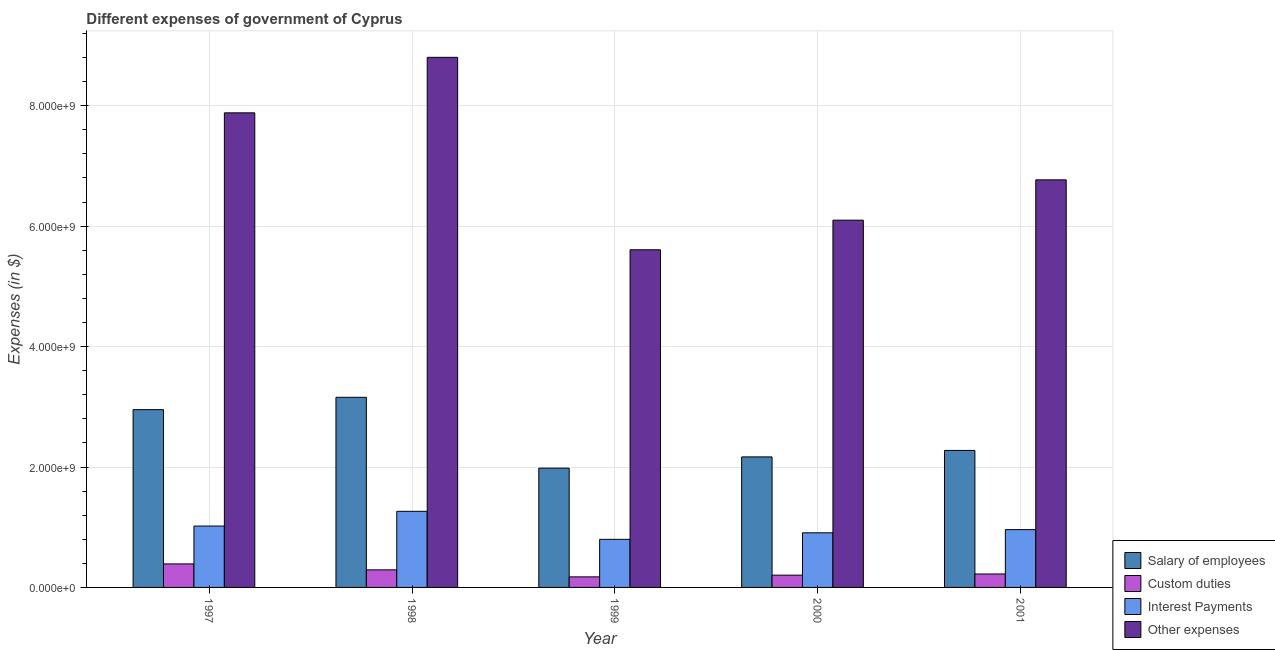Are the number of bars per tick equal to the number of legend labels?
Make the answer very short. Yes. How many bars are there on the 2nd tick from the right?
Give a very brief answer. 4. What is the label of the 2nd group of bars from the left?
Provide a short and direct response. 1998. What is the amount spent on salary of employees in 2000?
Keep it short and to the point. 2.17e+09. Across all years, what is the maximum amount spent on interest payments?
Your answer should be very brief. 1.26e+09. Across all years, what is the minimum amount spent on custom duties?
Give a very brief answer. 1.75e+08. In which year was the amount spent on salary of employees maximum?
Your answer should be very brief. 1998. What is the total amount spent on interest payments in the graph?
Ensure brevity in your answer.  4.95e+09. What is the difference between the amount spent on salary of employees in 1998 and that in 1999?
Your answer should be compact. 1.18e+09. What is the difference between the amount spent on other expenses in 1997 and the amount spent on salary of employees in 2000?
Provide a short and direct response. 1.78e+09. What is the average amount spent on other expenses per year?
Provide a succinct answer. 7.03e+09. What is the ratio of the amount spent on custom duties in 1998 to that in 2000?
Keep it short and to the point. 1.43. What is the difference between the highest and the second highest amount spent on interest payments?
Your answer should be compact. 2.45e+08. What is the difference between the highest and the lowest amount spent on custom duties?
Your answer should be very brief. 2.15e+08. Is the sum of the amount spent on interest payments in 1997 and 2000 greater than the maximum amount spent on custom duties across all years?
Offer a terse response. Yes. What does the 2nd bar from the left in 2001 represents?
Offer a very short reply. Custom duties. What does the 2nd bar from the right in 2000 represents?
Offer a very short reply. Interest Payments. Is it the case that in every year, the sum of the amount spent on salary of employees and amount spent on custom duties is greater than the amount spent on interest payments?
Provide a short and direct response. Yes. How many bars are there?
Give a very brief answer. 20. Are all the bars in the graph horizontal?
Your answer should be compact. No. What is the difference between two consecutive major ticks on the Y-axis?
Provide a short and direct response. 2.00e+09. Are the values on the major ticks of Y-axis written in scientific E-notation?
Offer a terse response. Yes. Does the graph contain grids?
Offer a very short reply. Yes. What is the title of the graph?
Ensure brevity in your answer.  Different expenses of government of Cyprus. Does "Secondary vocational education" appear as one of the legend labels in the graph?
Keep it short and to the point. No. What is the label or title of the X-axis?
Offer a very short reply. Year. What is the label or title of the Y-axis?
Your answer should be very brief. Expenses (in $). What is the Expenses (in $) in Salary of employees in 1997?
Offer a very short reply. 2.95e+09. What is the Expenses (in $) in Custom duties in 1997?
Ensure brevity in your answer.  3.91e+08. What is the Expenses (in $) in Interest Payments in 1997?
Provide a succinct answer. 1.02e+09. What is the Expenses (in $) of Other expenses in 1997?
Offer a very short reply. 7.88e+09. What is the Expenses (in $) of Salary of employees in 1998?
Ensure brevity in your answer.  3.16e+09. What is the Expenses (in $) of Custom duties in 1998?
Your answer should be compact. 2.92e+08. What is the Expenses (in $) in Interest Payments in 1998?
Your answer should be very brief. 1.26e+09. What is the Expenses (in $) of Other expenses in 1998?
Offer a very short reply. 8.80e+09. What is the Expenses (in $) in Salary of employees in 1999?
Make the answer very short. 1.98e+09. What is the Expenses (in $) of Custom duties in 1999?
Offer a terse response. 1.75e+08. What is the Expenses (in $) of Interest Payments in 1999?
Offer a very short reply. 7.99e+08. What is the Expenses (in $) in Other expenses in 1999?
Offer a terse response. 5.61e+09. What is the Expenses (in $) of Salary of employees in 2000?
Offer a terse response. 2.17e+09. What is the Expenses (in $) in Custom duties in 2000?
Keep it short and to the point. 2.04e+08. What is the Expenses (in $) in Interest Payments in 2000?
Offer a very short reply. 9.07e+08. What is the Expenses (in $) of Other expenses in 2000?
Provide a short and direct response. 6.10e+09. What is the Expenses (in $) in Salary of employees in 2001?
Your answer should be compact. 2.28e+09. What is the Expenses (in $) in Custom duties in 2001?
Keep it short and to the point. 2.23e+08. What is the Expenses (in $) of Interest Payments in 2001?
Your answer should be very brief. 9.60e+08. What is the Expenses (in $) in Other expenses in 2001?
Your response must be concise. 6.77e+09. Across all years, what is the maximum Expenses (in $) of Salary of employees?
Provide a short and direct response. 3.16e+09. Across all years, what is the maximum Expenses (in $) in Custom duties?
Your answer should be compact. 3.91e+08. Across all years, what is the maximum Expenses (in $) of Interest Payments?
Your answer should be very brief. 1.26e+09. Across all years, what is the maximum Expenses (in $) in Other expenses?
Offer a terse response. 8.80e+09. Across all years, what is the minimum Expenses (in $) of Salary of employees?
Your answer should be very brief. 1.98e+09. Across all years, what is the minimum Expenses (in $) in Custom duties?
Provide a short and direct response. 1.75e+08. Across all years, what is the minimum Expenses (in $) of Interest Payments?
Offer a terse response. 7.99e+08. Across all years, what is the minimum Expenses (in $) in Other expenses?
Offer a terse response. 5.61e+09. What is the total Expenses (in $) of Salary of employees in the graph?
Give a very brief answer. 1.25e+1. What is the total Expenses (in $) in Custom duties in the graph?
Give a very brief answer. 1.29e+09. What is the total Expenses (in $) of Interest Payments in the graph?
Offer a terse response. 4.95e+09. What is the total Expenses (in $) of Other expenses in the graph?
Your answer should be compact. 3.52e+1. What is the difference between the Expenses (in $) of Salary of employees in 1997 and that in 1998?
Ensure brevity in your answer.  -2.05e+08. What is the difference between the Expenses (in $) in Custom duties in 1997 and that in 1998?
Provide a short and direct response. 9.87e+07. What is the difference between the Expenses (in $) of Interest Payments in 1997 and that in 1998?
Offer a terse response. -2.45e+08. What is the difference between the Expenses (in $) of Other expenses in 1997 and that in 1998?
Give a very brief answer. -9.22e+08. What is the difference between the Expenses (in $) of Salary of employees in 1997 and that in 1999?
Give a very brief answer. 9.71e+08. What is the difference between the Expenses (in $) in Custom duties in 1997 and that in 1999?
Offer a terse response. 2.15e+08. What is the difference between the Expenses (in $) in Interest Payments in 1997 and that in 1999?
Keep it short and to the point. 2.20e+08. What is the difference between the Expenses (in $) of Other expenses in 1997 and that in 1999?
Ensure brevity in your answer.  2.27e+09. What is the difference between the Expenses (in $) of Salary of employees in 1997 and that in 2000?
Give a very brief answer. 7.85e+08. What is the difference between the Expenses (in $) of Custom duties in 1997 and that in 2000?
Ensure brevity in your answer.  1.87e+08. What is the difference between the Expenses (in $) in Interest Payments in 1997 and that in 2000?
Your response must be concise. 1.12e+08. What is the difference between the Expenses (in $) in Other expenses in 1997 and that in 2000?
Your answer should be compact. 1.78e+09. What is the difference between the Expenses (in $) of Salary of employees in 1997 and that in 2001?
Offer a terse response. 6.77e+08. What is the difference between the Expenses (in $) in Custom duties in 1997 and that in 2001?
Your answer should be very brief. 1.67e+08. What is the difference between the Expenses (in $) in Interest Payments in 1997 and that in 2001?
Provide a succinct answer. 5.91e+07. What is the difference between the Expenses (in $) of Other expenses in 1997 and that in 2001?
Offer a very short reply. 1.11e+09. What is the difference between the Expenses (in $) of Salary of employees in 1998 and that in 1999?
Provide a short and direct response. 1.18e+09. What is the difference between the Expenses (in $) of Custom duties in 1998 and that in 1999?
Offer a terse response. 1.16e+08. What is the difference between the Expenses (in $) of Interest Payments in 1998 and that in 1999?
Your answer should be very brief. 4.65e+08. What is the difference between the Expenses (in $) of Other expenses in 1998 and that in 1999?
Provide a short and direct response. 3.20e+09. What is the difference between the Expenses (in $) in Salary of employees in 1998 and that in 2000?
Your response must be concise. 9.90e+08. What is the difference between the Expenses (in $) in Custom duties in 1998 and that in 2000?
Offer a terse response. 8.79e+07. What is the difference between the Expenses (in $) in Interest Payments in 1998 and that in 2000?
Give a very brief answer. 3.57e+08. What is the difference between the Expenses (in $) in Other expenses in 1998 and that in 2000?
Offer a terse response. 2.70e+09. What is the difference between the Expenses (in $) in Salary of employees in 1998 and that in 2001?
Make the answer very short. 8.82e+08. What is the difference between the Expenses (in $) of Custom duties in 1998 and that in 2001?
Your answer should be compact. 6.86e+07. What is the difference between the Expenses (in $) of Interest Payments in 1998 and that in 2001?
Offer a terse response. 3.04e+08. What is the difference between the Expenses (in $) in Other expenses in 1998 and that in 2001?
Provide a succinct answer. 2.03e+09. What is the difference between the Expenses (in $) of Salary of employees in 1999 and that in 2000?
Offer a very short reply. -1.87e+08. What is the difference between the Expenses (in $) in Custom duties in 1999 and that in 2000?
Give a very brief answer. -2.85e+07. What is the difference between the Expenses (in $) of Interest Payments in 1999 and that in 2000?
Your answer should be very brief. -1.08e+08. What is the difference between the Expenses (in $) in Other expenses in 1999 and that in 2000?
Give a very brief answer. -4.92e+08. What is the difference between the Expenses (in $) of Salary of employees in 1999 and that in 2001?
Make the answer very short. -2.94e+08. What is the difference between the Expenses (in $) in Custom duties in 1999 and that in 2001?
Offer a terse response. -4.78e+07. What is the difference between the Expenses (in $) in Interest Payments in 1999 and that in 2001?
Make the answer very short. -1.61e+08. What is the difference between the Expenses (in $) of Other expenses in 1999 and that in 2001?
Offer a terse response. -1.16e+09. What is the difference between the Expenses (in $) of Salary of employees in 2000 and that in 2001?
Provide a succinct answer. -1.07e+08. What is the difference between the Expenses (in $) in Custom duties in 2000 and that in 2001?
Provide a succinct answer. -1.93e+07. What is the difference between the Expenses (in $) in Interest Payments in 2000 and that in 2001?
Make the answer very short. -5.28e+07. What is the difference between the Expenses (in $) of Other expenses in 2000 and that in 2001?
Provide a succinct answer. -6.70e+08. What is the difference between the Expenses (in $) in Salary of employees in 1997 and the Expenses (in $) in Custom duties in 1998?
Offer a very short reply. 2.66e+09. What is the difference between the Expenses (in $) of Salary of employees in 1997 and the Expenses (in $) of Interest Payments in 1998?
Offer a very short reply. 1.69e+09. What is the difference between the Expenses (in $) in Salary of employees in 1997 and the Expenses (in $) in Other expenses in 1998?
Make the answer very short. -5.85e+09. What is the difference between the Expenses (in $) of Custom duties in 1997 and the Expenses (in $) of Interest Payments in 1998?
Ensure brevity in your answer.  -8.73e+08. What is the difference between the Expenses (in $) of Custom duties in 1997 and the Expenses (in $) of Other expenses in 1998?
Offer a terse response. -8.41e+09. What is the difference between the Expenses (in $) in Interest Payments in 1997 and the Expenses (in $) in Other expenses in 1998?
Your answer should be very brief. -7.78e+09. What is the difference between the Expenses (in $) of Salary of employees in 1997 and the Expenses (in $) of Custom duties in 1999?
Give a very brief answer. 2.78e+09. What is the difference between the Expenses (in $) in Salary of employees in 1997 and the Expenses (in $) in Interest Payments in 1999?
Give a very brief answer. 2.15e+09. What is the difference between the Expenses (in $) of Salary of employees in 1997 and the Expenses (in $) of Other expenses in 1999?
Make the answer very short. -2.66e+09. What is the difference between the Expenses (in $) of Custom duties in 1997 and the Expenses (in $) of Interest Payments in 1999?
Provide a short and direct response. -4.08e+08. What is the difference between the Expenses (in $) in Custom duties in 1997 and the Expenses (in $) in Other expenses in 1999?
Your answer should be very brief. -5.22e+09. What is the difference between the Expenses (in $) of Interest Payments in 1997 and the Expenses (in $) of Other expenses in 1999?
Offer a terse response. -4.59e+09. What is the difference between the Expenses (in $) of Salary of employees in 1997 and the Expenses (in $) of Custom duties in 2000?
Offer a very short reply. 2.75e+09. What is the difference between the Expenses (in $) in Salary of employees in 1997 and the Expenses (in $) in Interest Payments in 2000?
Keep it short and to the point. 2.05e+09. What is the difference between the Expenses (in $) of Salary of employees in 1997 and the Expenses (in $) of Other expenses in 2000?
Provide a succinct answer. -3.15e+09. What is the difference between the Expenses (in $) of Custom duties in 1997 and the Expenses (in $) of Interest Payments in 2000?
Provide a short and direct response. -5.17e+08. What is the difference between the Expenses (in $) in Custom duties in 1997 and the Expenses (in $) in Other expenses in 2000?
Give a very brief answer. -5.71e+09. What is the difference between the Expenses (in $) of Interest Payments in 1997 and the Expenses (in $) of Other expenses in 2000?
Give a very brief answer. -5.08e+09. What is the difference between the Expenses (in $) of Salary of employees in 1997 and the Expenses (in $) of Custom duties in 2001?
Offer a very short reply. 2.73e+09. What is the difference between the Expenses (in $) of Salary of employees in 1997 and the Expenses (in $) of Interest Payments in 2001?
Ensure brevity in your answer.  1.99e+09. What is the difference between the Expenses (in $) in Salary of employees in 1997 and the Expenses (in $) in Other expenses in 2001?
Your answer should be very brief. -3.82e+09. What is the difference between the Expenses (in $) in Custom duties in 1997 and the Expenses (in $) in Interest Payments in 2001?
Provide a succinct answer. -5.69e+08. What is the difference between the Expenses (in $) of Custom duties in 1997 and the Expenses (in $) of Other expenses in 2001?
Provide a short and direct response. -6.38e+09. What is the difference between the Expenses (in $) in Interest Payments in 1997 and the Expenses (in $) in Other expenses in 2001?
Your answer should be compact. -5.75e+09. What is the difference between the Expenses (in $) of Salary of employees in 1998 and the Expenses (in $) of Custom duties in 1999?
Keep it short and to the point. 2.98e+09. What is the difference between the Expenses (in $) of Salary of employees in 1998 and the Expenses (in $) of Interest Payments in 1999?
Provide a succinct answer. 2.36e+09. What is the difference between the Expenses (in $) in Salary of employees in 1998 and the Expenses (in $) in Other expenses in 1999?
Offer a terse response. -2.45e+09. What is the difference between the Expenses (in $) of Custom duties in 1998 and the Expenses (in $) of Interest Payments in 1999?
Make the answer very short. -5.07e+08. What is the difference between the Expenses (in $) in Custom duties in 1998 and the Expenses (in $) in Other expenses in 1999?
Ensure brevity in your answer.  -5.32e+09. What is the difference between the Expenses (in $) in Interest Payments in 1998 and the Expenses (in $) in Other expenses in 1999?
Offer a terse response. -4.34e+09. What is the difference between the Expenses (in $) in Salary of employees in 1998 and the Expenses (in $) in Custom duties in 2000?
Offer a very short reply. 2.95e+09. What is the difference between the Expenses (in $) in Salary of employees in 1998 and the Expenses (in $) in Interest Payments in 2000?
Provide a short and direct response. 2.25e+09. What is the difference between the Expenses (in $) in Salary of employees in 1998 and the Expenses (in $) in Other expenses in 2000?
Make the answer very short. -2.94e+09. What is the difference between the Expenses (in $) of Custom duties in 1998 and the Expenses (in $) of Interest Payments in 2000?
Provide a short and direct response. -6.15e+08. What is the difference between the Expenses (in $) of Custom duties in 1998 and the Expenses (in $) of Other expenses in 2000?
Keep it short and to the point. -5.81e+09. What is the difference between the Expenses (in $) of Interest Payments in 1998 and the Expenses (in $) of Other expenses in 2000?
Give a very brief answer. -4.84e+09. What is the difference between the Expenses (in $) in Salary of employees in 1998 and the Expenses (in $) in Custom duties in 2001?
Offer a terse response. 2.93e+09. What is the difference between the Expenses (in $) in Salary of employees in 1998 and the Expenses (in $) in Interest Payments in 2001?
Offer a terse response. 2.20e+09. What is the difference between the Expenses (in $) of Salary of employees in 1998 and the Expenses (in $) of Other expenses in 2001?
Your answer should be very brief. -3.61e+09. What is the difference between the Expenses (in $) of Custom duties in 1998 and the Expenses (in $) of Interest Payments in 2001?
Your answer should be compact. -6.68e+08. What is the difference between the Expenses (in $) of Custom duties in 1998 and the Expenses (in $) of Other expenses in 2001?
Offer a terse response. -6.48e+09. What is the difference between the Expenses (in $) in Interest Payments in 1998 and the Expenses (in $) in Other expenses in 2001?
Ensure brevity in your answer.  -5.51e+09. What is the difference between the Expenses (in $) of Salary of employees in 1999 and the Expenses (in $) of Custom duties in 2000?
Ensure brevity in your answer.  1.78e+09. What is the difference between the Expenses (in $) in Salary of employees in 1999 and the Expenses (in $) in Interest Payments in 2000?
Your answer should be very brief. 1.07e+09. What is the difference between the Expenses (in $) in Salary of employees in 1999 and the Expenses (in $) in Other expenses in 2000?
Ensure brevity in your answer.  -4.12e+09. What is the difference between the Expenses (in $) in Custom duties in 1999 and the Expenses (in $) in Interest Payments in 2000?
Provide a short and direct response. -7.32e+08. What is the difference between the Expenses (in $) in Custom duties in 1999 and the Expenses (in $) in Other expenses in 2000?
Ensure brevity in your answer.  -5.92e+09. What is the difference between the Expenses (in $) of Interest Payments in 1999 and the Expenses (in $) of Other expenses in 2000?
Your answer should be compact. -5.30e+09. What is the difference between the Expenses (in $) in Salary of employees in 1999 and the Expenses (in $) in Custom duties in 2001?
Your answer should be compact. 1.76e+09. What is the difference between the Expenses (in $) in Salary of employees in 1999 and the Expenses (in $) in Interest Payments in 2001?
Your answer should be very brief. 1.02e+09. What is the difference between the Expenses (in $) in Salary of employees in 1999 and the Expenses (in $) in Other expenses in 2001?
Your answer should be very brief. -4.79e+09. What is the difference between the Expenses (in $) of Custom duties in 1999 and the Expenses (in $) of Interest Payments in 2001?
Keep it short and to the point. -7.85e+08. What is the difference between the Expenses (in $) in Custom duties in 1999 and the Expenses (in $) in Other expenses in 2001?
Provide a succinct answer. -6.59e+09. What is the difference between the Expenses (in $) of Interest Payments in 1999 and the Expenses (in $) of Other expenses in 2001?
Provide a short and direct response. -5.97e+09. What is the difference between the Expenses (in $) in Salary of employees in 2000 and the Expenses (in $) in Custom duties in 2001?
Ensure brevity in your answer.  1.94e+09. What is the difference between the Expenses (in $) in Salary of employees in 2000 and the Expenses (in $) in Interest Payments in 2001?
Give a very brief answer. 1.21e+09. What is the difference between the Expenses (in $) of Salary of employees in 2000 and the Expenses (in $) of Other expenses in 2001?
Your answer should be compact. -4.60e+09. What is the difference between the Expenses (in $) in Custom duties in 2000 and the Expenses (in $) in Interest Payments in 2001?
Keep it short and to the point. -7.56e+08. What is the difference between the Expenses (in $) of Custom duties in 2000 and the Expenses (in $) of Other expenses in 2001?
Ensure brevity in your answer.  -6.57e+09. What is the difference between the Expenses (in $) in Interest Payments in 2000 and the Expenses (in $) in Other expenses in 2001?
Your answer should be very brief. -5.86e+09. What is the average Expenses (in $) in Salary of employees per year?
Ensure brevity in your answer.  2.51e+09. What is the average Expenses (in $) of Custom duties per year?
Provide a short and direct response. 2.57e+08. What is the average Expenses (in $) of Interest Payments per year?
Provide a succinct answer. 9.90e+08. What is the average Expenses (in $) in Other expenses per year?
Provide a succinct answer. 7.03e+09. In the year 1997, what is the difference between the Expenses (in $) in Salary of employees and Expenses (in $) in Custom duties?
Your answer should be compact. 2.56e+09. In the year 1997, what is the difference between the Expenses (in $) of Salary of employees and Expenses (in $) of Interest Payments?
Give a very brief answer. 1.93e+09. In the year 1997, what is the difference between the Expenses (in $) of Salary of employees and Expenses (in $) of Other expenses?
Your answer should be very brief. -4.93e+09. In the year 1997, what is the difference between the Expenses (in $) in Custom duties and Expenses (in $) in Interest Payments?
Provide a succinct answer. -6.29e+08. In the year 1997, what is the difference between the Expenses (in $) of Custom duties and Expenses (in $) of Other expenses?
Ensure brevity in your answer.  -7.49e+09. In the year 1997, what is the difference between the Expenses (in $) in Interest Payments and Expenses (in $) in Other expenses?
Make the answer very short. -6.86e+09. In the year 1998, what is the difference between the Expenses (in $) of Salary of employees and Expenses (in $) of Custom duties?
Your answer should be compact. 2.87e+09. In the year 1998, what is the difference between the Expenses (in $) in Salary of employees and Expenses (in $) in Interest Payments?
Give a very brief answer. 1.89e+09. In the year 1998, what is the difference between the Expenses (in $) of Salary of employees and Expenses (in $) of Other expenses?
Your response must be concise. -5.65e+09. In the year 1998, what is the difference between the Expenses (in $) of Custom duties and Expenses (in $) of Interest Payments?
Your answer should be very brief. -9.72e+08. In the year 1998, what is the difference between the Expenses (in $) in Custom duties and Expenses (in $) in Other expenses?
Your answer should be very brief. -8.51e+09. In the year 1998, what is the difference between the Expenses (in $) in Interest Payments and Expenses (in $) in Other expenses?
Ensure brevity in your answer.  -7.54e+09. In the year 1999, what is the difference between the Expenses (in $) in Salary of employees and Expenses (in $) in Custom duties?
Offer a terse response. 1.81e+09. In the year 1999, what is the difference between the Expenses (in $) in Salary of employees and Expenses (in $) in Interest Payments?
Provide a succinct answer. 1.18e+09. In the year 1999, what is the difference between the Expenses (in $) in Salary of employees and Expenses (in $) in Other expenses?
Your answer should be very brief. -3.63e+09. In the year 1999, what is the difference between the Expenses (in $) of Custom duties and Expenses (in $) of Interest Payments?
Provide a short and direct response. -6.23e+08. In the year 1999, what is the difference between the Expenses (in $) of Custom duties and Expenses (in $) of Other expenses?
Offer a very short reply. -5.43e+09. In the year 1999, what is the difference between the Expenses (in $) in Interest Payments and Expenses (in $) in Other expenses?
Offer a very short reply. -4.81e+09. In the year 2000, what is the difference between the Expenses (in $) in Salary of employees and Expenses (in $) in Custom duties?
Give a very brief answer. 1.96e+09. In the year 2000, what is the difference between the Expenses (in $) of Salary of employees and Expenses (in $) of Interest Payments?
Your response must be concise. 1.26e+09. In the year 2000, what is the difference between the Expenses (in $) in Salary of employees and Expenses (in $) in Other expenses?
Keep it short and to the point. -3.93e+09. In the year 2000, what is the difference between the Expenses (in $) in Custom duties and Expenses (in $) in Interest Payments?
Provide a short and direct response. -7.03e+08. In the year 2000, what is the difference between the Expenses (in $) in Custom duties and Expenses (in $) in Other expenses?
Give a very brief answer. -5.90e+09. In the year 2000, what is the difference between the Expenses (in $) in Interest Payments and Expenses (in $) in Other expenses?
Ensure brevity in your answer.  -5.19e+09. In the year 2001, what is the difference between the Expenses (in $) of Salary of employees and Expenses (in $) of Custom duties?
Offer a terse response. 2.05e+09. In the year 2001, what is the difference between the Expenses (in $) in Salary of employees and Expenses (in $) in Interest Payments?
Offer a very short reply. 1.32e+09. In the year 2001, what is the difference between the Expenses (in $) in Salary of employees and Expenses (in $) in Other expenses?
Give a very brief answer. -4.49e+09. In the year 2001, what is the difference between the Expenses (in $) of Custom duties and Expenses (in $) of Interest Payments?
Your response must be concise. -7.37e+08. In the year 2001, what is the difference between the Expenses (in $) of Custom duties and Expenses (in $) of Other expenses?
Keep it short and to the point. -6.55e+09. In the year 2001, what is the difference between the Expenses (in $) in Interest Payments and Expenses (in $) in Other expenses?
Offer a very short reply. -5.81e+09. What is the ratio of the Expenses (in $) of Salary of employees in 1997 to that in 1998?
Your answer should be compact. 0.94. What is the ratio of the Expenses (in $) in Custom duties in 1997 to that in 1998?
Provide a short and direct response. 1.34. What is the ratio of the Expenses (in $) of Interest Payments in 1997 to that in 1998?
Keep it short and to the point. 0.81. What is the ratio of the Expenses (in $) of Other expenses in 1997 to that in 1998?
Your answer should be compact. 0.9. What is the ratio of the Expenses (in $) in Salary of employees in 1997 to that in 1999?
Keep it short and to the point. 1.49. What is the ratio of the Expenses (in $) in Custom duties in 1997 to that in 1999?
Make the answer very short. 2.23. What is the ratio of the Expenses (in $) in Interest Payments in 1997 to that in 1999?
Offer a terse response. 1.28. What is the ratio of the Expenses (in $) in Other expenses in 1997 to that in 1999?
Keep it short and to the point. 1.41. What is the ratio of the Expenses (in $) of Salary of employees in 1997 to that in 2000?
Provide a short and direct response. 1.36. What is the ratio of the Expenses (in $) in Custom duties in 1997 to that in 2000?
Make the answer very short. 1.91. What is the ratio of the Expenses (in $) in Interest Payments in 1997 to that in 2000?
Your response must be concise. 1.12. What is the ratio of the Expenses (in $) in Other expenses in 1997 to that in 2000?
Provide a short and direct response. 1.29. What is the ratio of the Expenses (in $) of Salary of employees in 1997 to that in 2001?
Keep it short and to the point. 1.3. What is the ratio of the Expenses (in $) in Custom duties in 1997 to that in 2001?
Your answer should be compact. 1.75. What is the ratio of the Expenses (in $) in Interest Payments in 1997 to that in 2001?
Offer a terse response. 1.06. What is the ratio of the Expenses (in $) in Other expenses in 1997 to that in 2001?
Give a very brief answer. 1.16. What is the ratio of the Expenses (in $) in Salary of employees in 1998 to that in 1999?
Offer a terse response. 1.59. What is the ratio of the Expenses (in $) of Custom duties in 1998 to that in 1999?
Keep it short and to the point. 1.66. What is the ratio of the Expenses (in $) of Interest Payments in 1998 to that in 1999?
Give a very brief answer. 1.58. What is the ratio of the Expenses (in $) of Other expenses in 1998 to that in 1999?
Provide a succinct answer. 1.57. What is the ratio of the Expenses (in $) in Salary of employees in 1998 to that in 2000?
Offer a very short reply. 1.46. What is the ratio of the Expenses (in $) of Custom duties in 1998 to that in 2000?
Your answer should be compact. 1.43. What is the ratio of the Expenses (in $) of Interest Payments in 1998 to that in 2000?
Offer a terse response. 1.39. What is the ratio of the Expenses (in $) in Other expenses in 1998 to that in 2000?
Provide a short and direct response. 1.44. What is the ratio of the Expenses (in $) of Salary of employees in 1998 to that in 2001?
Provide a short and direct response. 1.39. What is the ratio of the Expenses (in $) of Custom duties in 1998 to that in 2001?
Keep it short and to the point. 1.31. What is the ratio of the Expenses (in $) in Interest Payments in 1998 to that in 2001?
Your answer should be compact. 1.32. What is the ratio of the Expenses (in $) in Other expenses in 1998 to that in 2001?
Offer a very short reply. 1.3. What is the ratio of the Expenses (in $) in Salary of employees in 1999 to that in 2000?
Provide a succinct answer. 0.91. What is the ratio of the Expenses (in $) in Custom duties in 1999 to that in 2000?
Your response must be concise. 0.86. What is the ratio of the Expenses (in $) in Interest Payments in 1999 to that in 2000?
Give a very brief answer. 0.88. What is the ratio of the Expenses (in $) in Other expenses in 1999 to that in 2000?
Provide a short and direct response. 0.92. What is the ratio of the Expenses (in $) in Salary of employees in 1999 to that in 2001?
Provide a succinct answer. 0.87. What is the ratio of the Expenses (in $) in Custom duties in 1999 to that in 2001?
Ensure brevity in your answer.  0.79. What is the ratio of the Expenses (in $) in Interest Payments in 1999 to that in 2001?
Your answer should be compact. 0.83. What is the ratio of the Expenses (in $) in Other expenses in 1999 to that in 2001?
Provide a short and direct response. 0.83. What is the ratio of the Expenses (in $) of Salary of employees in 2000 to that in 2001?
Your response must be concise. 0.95. What is the ratio of the Expenses (in $) in Custom duties in 2000 to that in 2001?
Give a very brief answer. 0.91. What is the ratio of the Expenses (in $) in Interest Payments in 2000 to that in 2001?
Provide a succinct answer. 0.94. What is the ratio of the Expenses (in $) of Other expenses in 2000 to that in 2001?
Make the answer very short. 0.9. What is the difference between the highest and the second highest Expenses (in $) of Salary of employees?
Your answer should be very brief. 2.05e+08. What is the difference between the highest and the second highest Expenses (in $) in Custom duties?
Give a very brief answer. 9.87e+07. What is the difference between the highest and the second highest Expenses (in $) in Interest Payments?
Make the answer very short. 2.45e+08. What is the difference between the highest and the second highest Expenses (in $) of Other expenses?
Ensure brevity in your answer.  9.22e+08. What is the difference between the highest and the lowest Expenses (in $) in Salary of employees?
Your answer should be very brief. 1.18e+09. What is the difference between the highest and the lowest Expenses (in $) in Custom duties?
Provide a succinct answer. 2.15e+08. What is the difference between the highest and the lowest Expenses (in $) of Interest Payments?
Your answer should be very brief. 4.65e+08. What is the difference between the highest and the lowest Expenses (in $) in Other expenses?
Keep it short and to the point. 3.20e+09. 